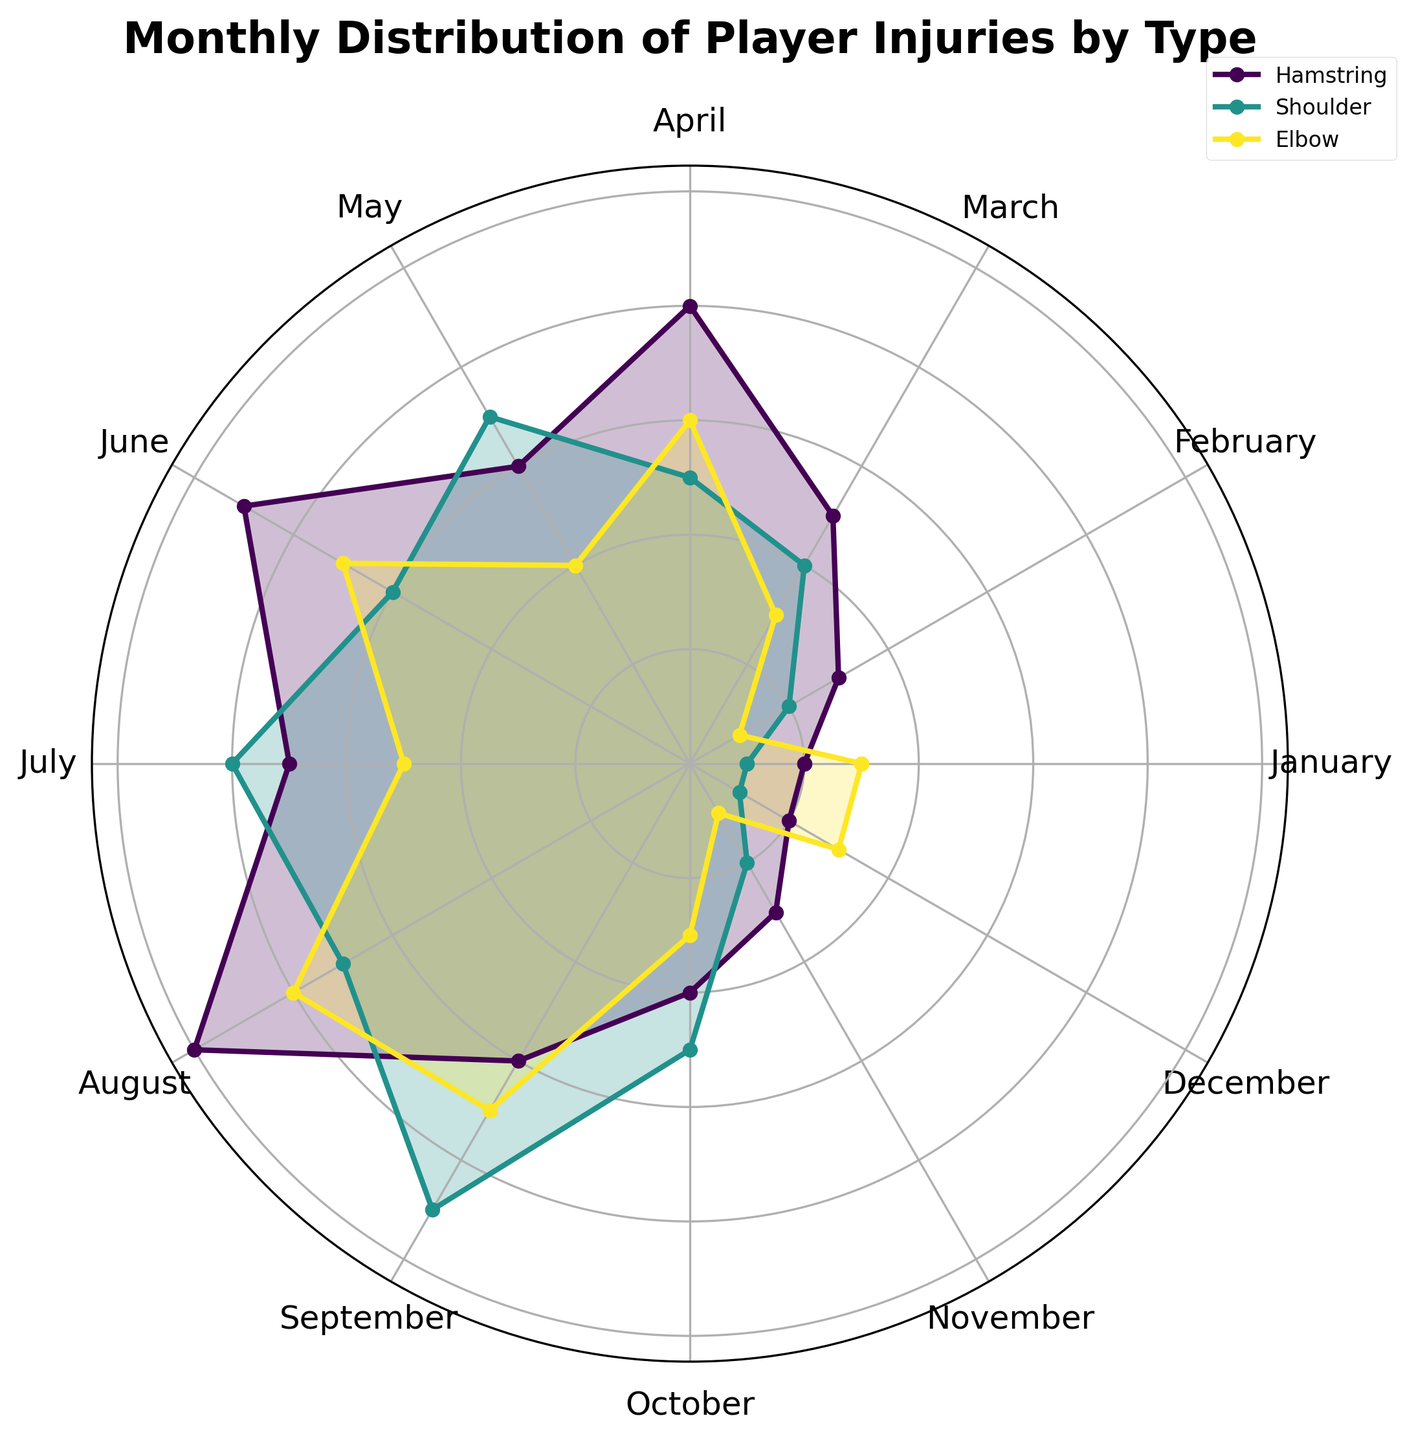Which month has the highest number of hamstring injuries? To find the month with the highest number of hamstring injuries, locate the segment corresponding to Hamstring injuries and identify the month where the plot's radius is the largest. August shows the largest radius for Hamstring injuries.
Answer: August Which injury type has the highest count in July? Look at the segments for July and compare the radii for each injury type (Hamstring, Shoulder, and Elbow). The segment for Shoulder injuries has the greatest radius in July.
Answer: Shoulder What is the total number of injuries in April? Sum the counts for all injury types in April: Hamstring (8), Shoulder (5), and Elbow (6). The total count is 8 + 5 + 6.
Answer: 19 Which month has the least number of injuries, and what is the injury type? Globally compare the radii of segments across all months and injury types. Both January and December have the smallest radii, specifically for Shoulder injuries.
Answer: January and December, Shoulder Are there months where shoulder injuries are higher than both hamstring and elbow injuries? Compare Shoulder injuries visually against Hamstring and Elbow injury segments for each month. Shoulder injuries are higher in July and September.
Answer: July and September During which month do elbow injuries peak? Find the month where the Elbow injury segment reaches its highest point. August shows the largest radius for Elbow injuries.
Answer: August How do hamstring injuries in May compare to those in June? Compare the radii for Hamstring injuries in May and June. The Hamstring injury segment in June is longer than in May, indicating higher injuries.
Answer: June has higher hamstring injuries than May Is there a month where the count of any injury type is equal across January and December? Examine January and December data segments for equal radii across any injury type. Both January and December show Elbow injuries with an equal count of 3.
Answer: Yes, Elbow What is the average number of shoulder injuries across all months? Sum the counts of Shoulder injuries for all months (1+2+4+5+7+6+8+7+9+5+2+1 = 57). Then, divide by the number of months (12). The average is 57/12.
Answer: 4.75 In which month are the number of injuries evenly distributed across all types? Look for months where the segments for all injury types have nearly the same radius. February has counts close to one another (Hamstring 3, Shoulder 2, Elbow 1).
Answer: February 